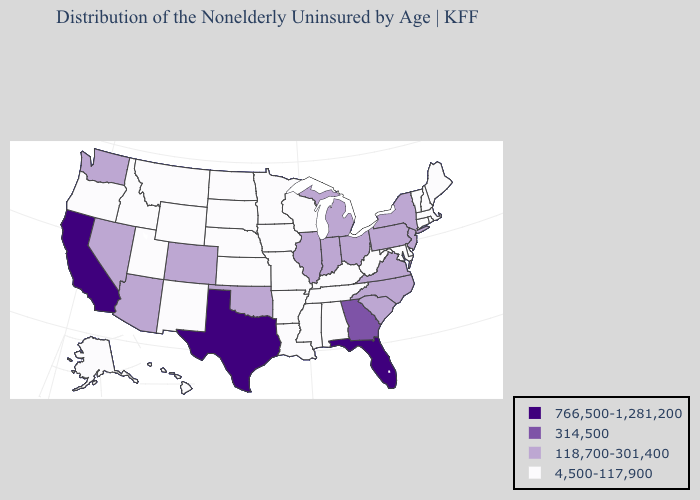What is the highest value in the USA?
Answer briefly. 766,500-1,281,200. What is the value of Utah?
Give a very brief answer. 4,500-117,900. Name the states that have a value in the range 314,500?
Give a very brief answer. Georgia. Which states have the highest value in the USA?
Keep it brief. California, Florida, Texas. Does Utah have the highest value in the USA?
Concise answer only. No. How many symbols are there in the legend?
Be succinct. 4. Does Florida have the lowest value in the South?
Concise answer only. No. Name the states that have a value in the range 4,500-117,900?
Quick response, please. Alabama, Alaska, Arkansas, Connecticut, Delaware, Hawaii, Idaho, Iowa, Kansas, Kentucky, Louisiana, Maine, Maryland, Massachusetts, Minnesota, Mississippi, Missouri, Montana, Nebraska, New Hampshire, New Mexico, North Dakota, Oregon, Rhode Island, South Dakota, Tennessee, Utah, Vermont, West Virginia, Wisconsin, Wyoming. Among the states that border Arkansas , does Texas have the highest value?
Answer briefly. Yes. What is the value of Pennsylvania?
Write a very short answer. 118,700-301,400. What is the lowest value in the USA?
Answer briefly. 4,500-117,900. Does Arkansas have the lowest value in the South?
Be succinct. Yes. What is the value of Maine?
Give a very brief answer. 4,500-117,900. Does Arizona have the lowest value in the USA?
Answer briefly. No. 